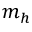<formula> <loc_0><loc_0><loc_500><loc_500>m _ { h }</formula> 